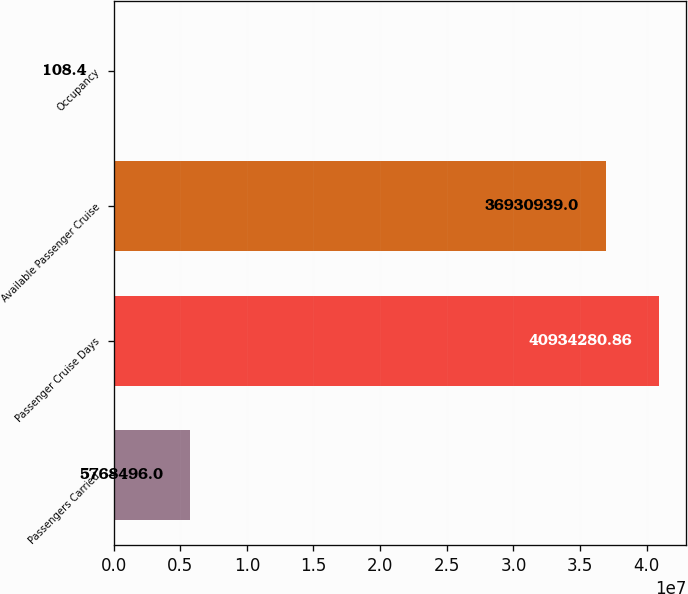Convert chart. <chart><loc_0><loc_0><loc_500><loc_500><bar_chart><fcel>Passengers Carried<fcel>Passenger Cruise Days<fcel>Available Passenger Cruise<fcel>Occupancy<nl><fcel>5.7685e+06<fcel>4.09343e+07<fcel>3.69309e+07<fcel>108.4<nl></chart> 